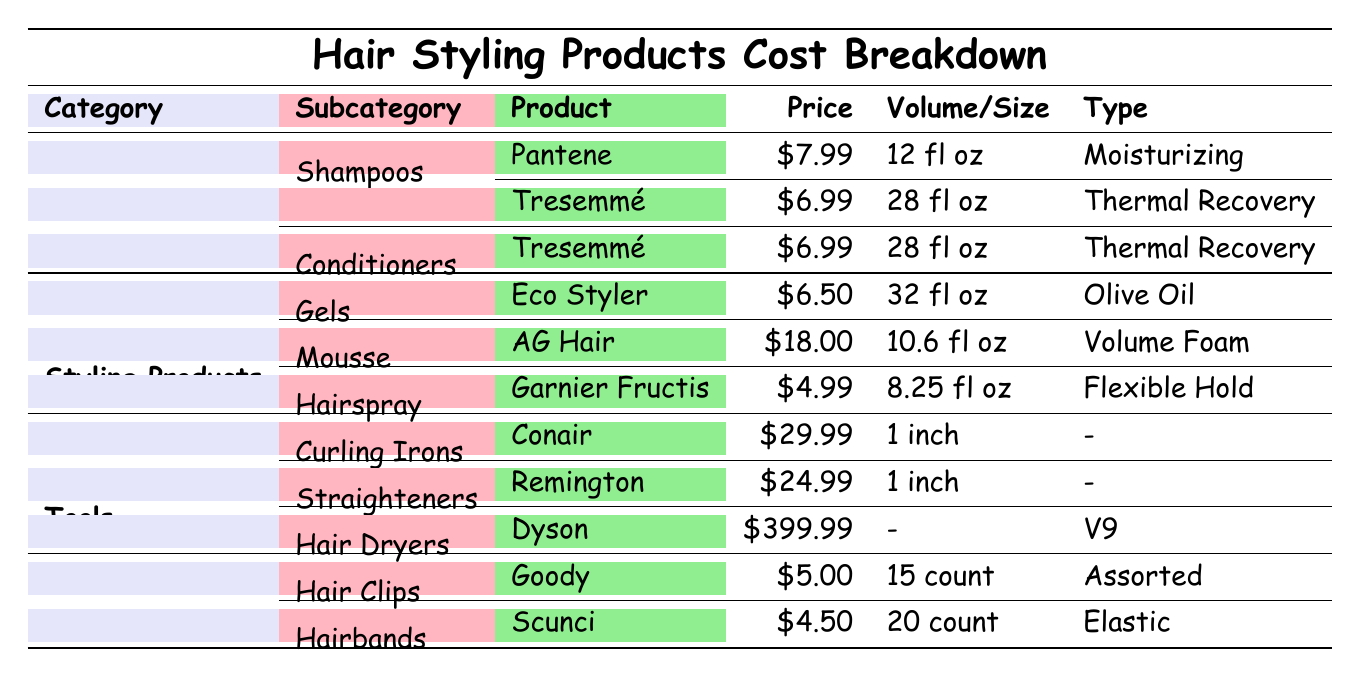What is the price of the Pantene shampoo? The table lists Pantene under the Shampoos subcategory in the Hair Care section, showing a price of $7.99.
Answer: $7.99 How many fluid ounces are in the Tresemmé conditioner? The Tresemmé conditioner is specified in the table under the Conditioners subcategory in Hair Care, and its volume is stated as 28 fl oz.
Answer: 28 fl oz Which styling product is the most expensive? Looking at the Styling Products section, the products listed are Mousse ($18.00), Gels ($6.50), and Hairspray ($4.99). The product with the highest price is AG Hair Mousse, which is $18.00.
Answer: AG Hair Mousse at $18.00 What is the total cost of all the hair care products? The hair care products are Pantene ($7.99) and Tresemmé Conditioner ($6.99). Adding these gives $7.99 + $6.99 = $14.98 as the total cost.
Answer: $14.98 Is the Garnier Fructis hairspray more expensive than the Eco Styler gel? The table shows Garnier Fructis hairspray at $4.99 and Eco Styler gel at $6.50. Since $4.99 is less than $6.50, the answer is no.
Answer: No How much do the tools for styling hair cost in total? The tools are Conair Curling Irons ($29.99), Remington Straighteners ($24.99), and Dyson Hair Dryers ($399.99). Summing these costs gives: $29.99 + $24.99 + $399.99 = $454.97.
Answer: $454.97 Are there more hair clips or hairbands available? The table lists 15 counts of Goody Hair Clips and 20 counts of Scunci Hairbands. Since 20 is greater than 15, there are more hairbands.
Answer: Yes What is the average price of products in the Accessories category? The products in the Accessories category are Hair Clips ($5.00) and Hairbands ($4.50). Their total is $5.00 + $4.50 = $9.50. The average price is $9.50 divided by 2, which equals $4.75.
Answer: $4.75 